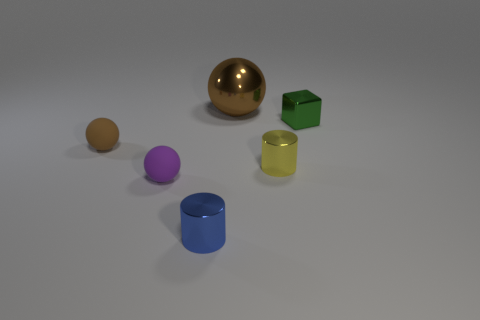Add 4 small brown rubber spheres. How many objects exist? 10 Subtract 0 cyan cylinders. How many objects are left? 6 Subtract all cylinders. How many objects are left? 4 Subtract all large brown spheres. Subtract all yellow metallic things. How many objects are left? 4 Add 5 small cylinders. How many small cylinders are left? 7 Add 2 purple blocks. How many purple blocks exist? 2 